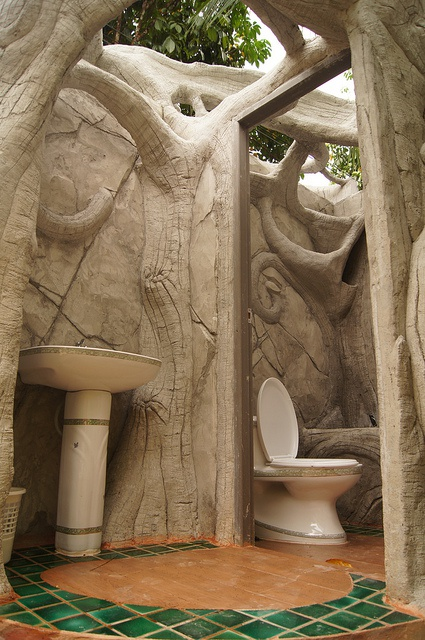Describe the objects in this image and their specific colors. I can see sink in darkgray, tan, gray, and maroon tones and toilet in darkgray, tan, gray, and maroon tones in this image. 